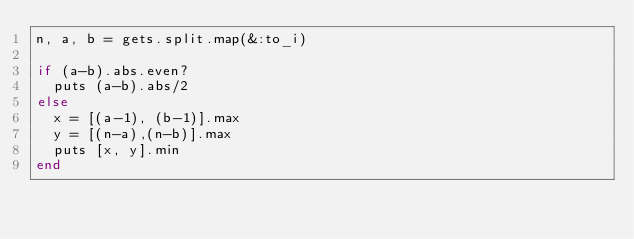Convert code to text. <code><loc_0><loc_0><loc_500><loc_500><_Ruby_>n, a, b = gets.split.map(&:to_i)

if (a-b).abs.even?
  puts (a-b).abs/2
else
  x = [(a-1), (b-1)].max
  y = [(n-a),(n-b)].max
  puts [x, y].min
end</code> 